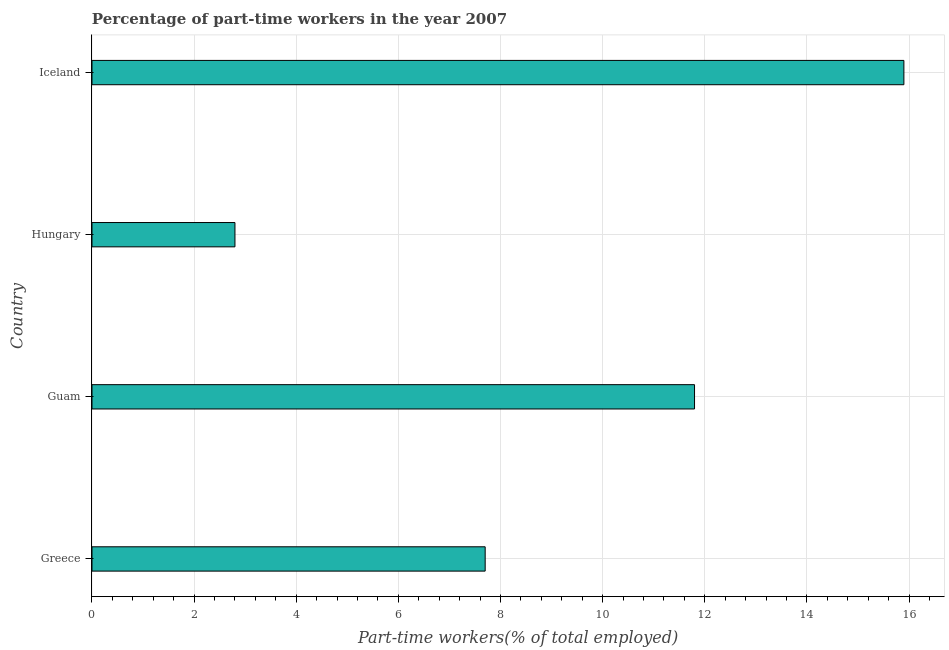Does the graph contain any zero values?
Give a very brief answer. No. Does the graph contain grids?
Provide a succinct answer. Yes. What is the title of the graph?
Keep it short and to the point. Percentage of part-time workers in the year 2007. What is the label or title of the X-axis?
Ensure brevity in your answer.  Part-time workers(% of total employed). What is the label or title of the Y-axis?
Your response must be concise. Country. What is the percentage of part-time workers in Guam?
Your response must be concise. 11.8. Across all countries, what is the maximum percentage of part-time workers?
Your answer should be compact. 15.9. Across all countries, what is the minimum percentage of part-time workers?
Your response must be concise. 2.8. In which country was the percentage of part-time workers maximum?
Provide a short and direct response. Iceland. In which country was the percentage of part-time workers minimum?
Provide a short and direct response. Hungary. What is the sum of the percentage of part-time workers?
Provide a short and direct response. 38.2. What is the average percentage of part-time workers per country?
Your answer should be compact. 9.55. What is the median percentage of part-time workers?
Offer a terse response. 9.75. In how many countries, is the percentage of part-time workers greater than 14.4 %?
Your response must be concise. 1. What is the ratio of the percentage of part-time workers in Hungary to that in Iceland?
Your answer should be compact. 0.18. What is the difference between the highest and the second highest percentage of part-time workers?
Give a very brief answer. 4.1. What is the difference between the highest and the lowest percentage of part-time workers?
Make the answer very short. 13.1. How many bars are there?
Your answer should be compact. 4. What is the difference between two consecutive major ticks on the X-axis?
Your response must be concise. 2. What is the Part-time workers(% of total employed) of Greece?
Offer a very short reply. 7.7. What is the Part-time workers(% of total employed) in Guam?
Provide a succinct answer. 11.8. What is the Part-time workers(% of total employed) in Hungary?
Offer a very short reply. 2.8. What is the Part-time workers(% of total employed) of Iceland?
Ensure brevity in your answer.  15.9. What is the difference between the Part-time workers(% of total employed) in Greece and Hungary?
Provide a short and direct response. 4.9. What is the difference between the Part-time workers(% of total employed) in Greece and Iceland?
Your answer should be compact. -8.2. What is the difference between the Part-time workers(% of total employed) in Guam and Hungary?
Your answer should be compact. 9. What is the difference between the Part-time workers(% of total employed) in Hungary and Iceland?
Ensure brevity in your answer.  -13.1. What is the ratio of the Part-time workers(% of total employed) in Greece to that in Guam?
Provide a succinct answer. 0.65. What is the ratio of the Part-time workers(% of total employed) in Greece to that in Hungary?
Make the answer very short. 2.75. What is the ratio of the Part-time workers(% of total employed) in Greece to that in Iceland?
Your answer should be compact. 0.48. What is the ratio of the Part-time workers(% of total employed) in Guam to that in Hungary?
Provide a short and direct response. 4.21. What is the ratio of the Part-time workers(% of total employed) in Guam to that in Iceland?
Offer a very short reply. 0.74. What is the ratio of the Part-time workers(% of total employed) in Hungary to that in Iceland?
Your answer should be compact. 0.18. 